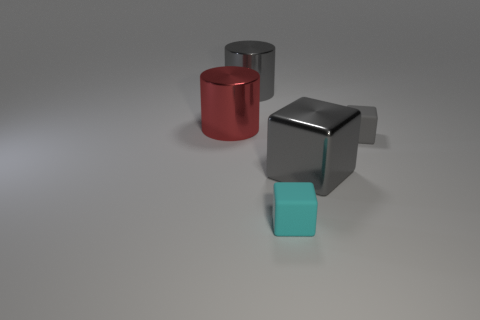What is the shape of the gray object in front of the small rubber block on the right side of the gray metal block?
Give a very brief answer. Cube. There is a gray rubber thing that is the same size as the cyan block; what shape is it?
Keep it short and to the point. Cube. Is there a gray object that has the same shape as the small cyan object?
Your answer should be compact. Yes. What is the material of the tiny cyan object?
Give a very brief answer. Rubber. There is a red metal cylinder; are there any cyan blocks in front of it?
Make the answer very short. Yes. There is a big gray metal object that is in front of the red object; what number of blocks are in front of it?
Provide a short and direct response. 1. What material is the gray thing that is the same size as the cyan cube?
Offer a very short reply. Rubber. What number of other things are the same material as the large red cylinder?
Offer a terse response. 2. What number of shiny cylinders are behind the red metal cylinder?
Your answer should be very brief. 1. How many blocks are small cyan matte objects or tiny gray matte objects?
Provide a short and direct response. 2. 